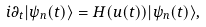Convert formula to latex. <formula><loc_0><loc_0><loc_500><loc_500>i \partial _ { t } | \psi _ { n } ( t ) \rangle = H ( u ( t ) ) | \psi _ { n } ( t ) \rangle ,</formula> 